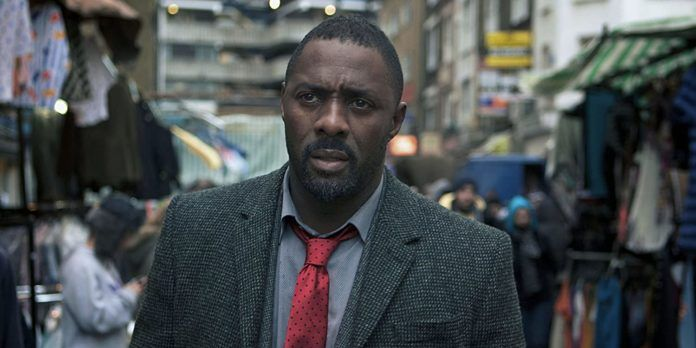From what you can see, is this a recent scene or does it feel like it captures a different period? The image gives a timeless feel due to the generic setup of a busy street market and the attire of the character. The grey tweed jacket and red tie worn by Idris Elba’s character bring a classic, almost vintage touch, whereas the surrounding modern market stalls and urban background indicate a contemporary setting. This juxtaposition suggests an interplay between timeless detective work and present-day scenarios. How does the background contribute to the overall narrative of the character? The bustling market background adds a layer of realism and urgency to the scene. It situates DCI John Luther amidst everyday life, underscoring the notion that crime and investigation are intrinsic parts of the modern urban fabric. The crowded stalls and moving people symbolize the chaos and complexity of the city, reflecting the convoluted cases Luther often deals with. Moreover, the vibrant activity contrasts with Luther’s serious demeanor, highlighting his isolation and singular focus in the labyrinth of urban life. Imagine if this scene was part of a surreal narrative. What elements would you add or change? To transform this scene into a surreal narrative, you could introduce fantastical elements like floating market stalls or animals walking on hind legs. Neon-lit floating signs with cryptic messages could hover over the market, hinting at a deeper mystery. The sky could be an unusual color, perhaps a deep purple or emerald green, with ethereal mist swirling around. Luther could be holding an unusual artifact glowing with an eerie light, indicating its significance beyond normal comprehension. In the background, surreal characters like a street magician performing actual magic or a timeless figure like a clock-faced person could wander, adding layers of unpredictability and wonder to the scene. 